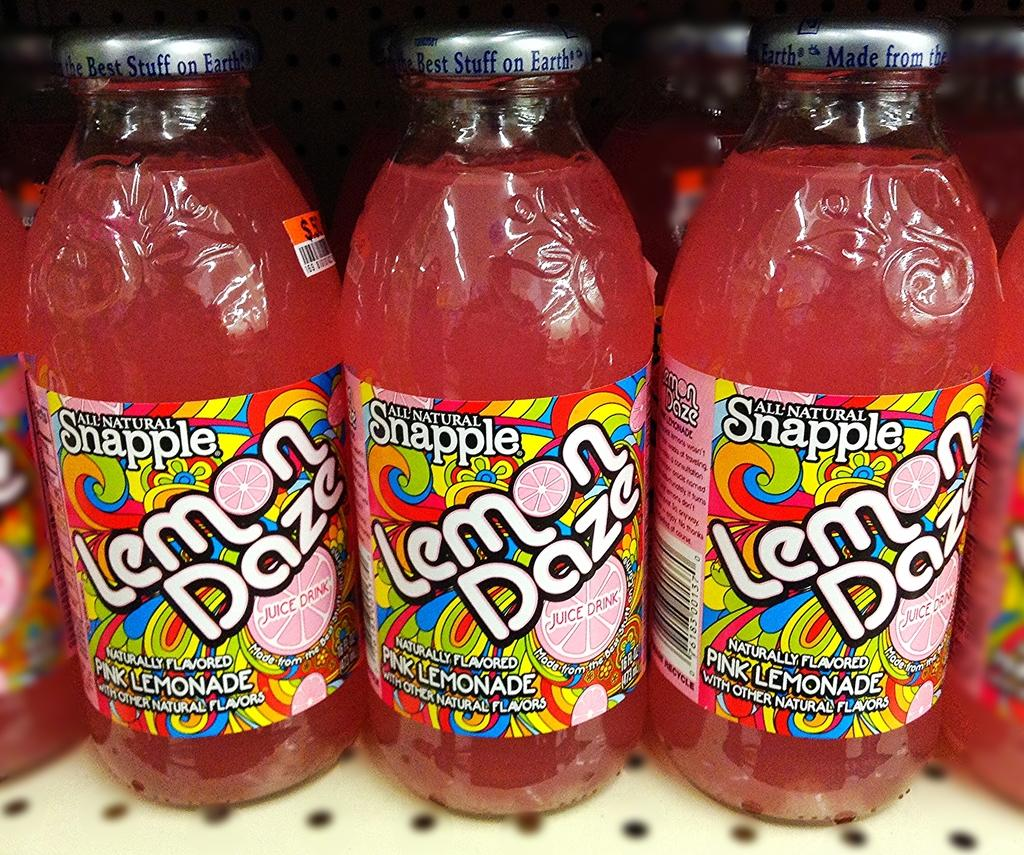<image>
Present a compact description of the photo's key features. A store display of Lemon Daze Snapple drink. 